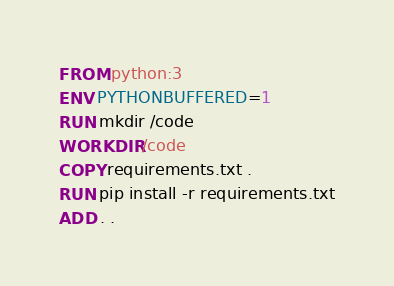Convert code to text. <code><loc_0><loc_0><loc_500><loc_500><_Dockerfile_>FROM python:3
ENV PYTHONBUFFERED=1
RUN mkdir /code
WORKDIR /code
COPY requirements.txt .
RUN pip install -r requirements.txt
ADD . .</code> 